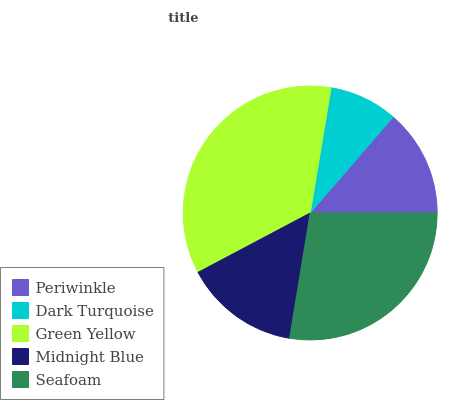Is Dark Turquoise the minimum?
Answer yes or no. Yes. Is Green Yellow the maximum?
Answer yes or no. Yes. Is Green Yellow the minimum?
Answer yes or no. No. Is Dark Turquoise the maximum?
Answer yes or no. No. Is Green Yellow greater than Dark Turquoise?
Answer yes or no. Yes. Is Dark Turquoise less than Green Yellow?
Answer yes or no. Yes. Is Dark Turquoise greater than Green Yellow?
Answer yes or no. No. Is Green Yellow less than Dark Turquoise?
Answer yes or no. No. Is Midnight Blue the high median?
Answer yes or no. Yes. Is Midnight Blue the low median?
Answer yes or no. Yes. Is Seafoam the high median?
Answer yes or no. No. Is Periwinkle the low median?
Answer yes or no. No. 